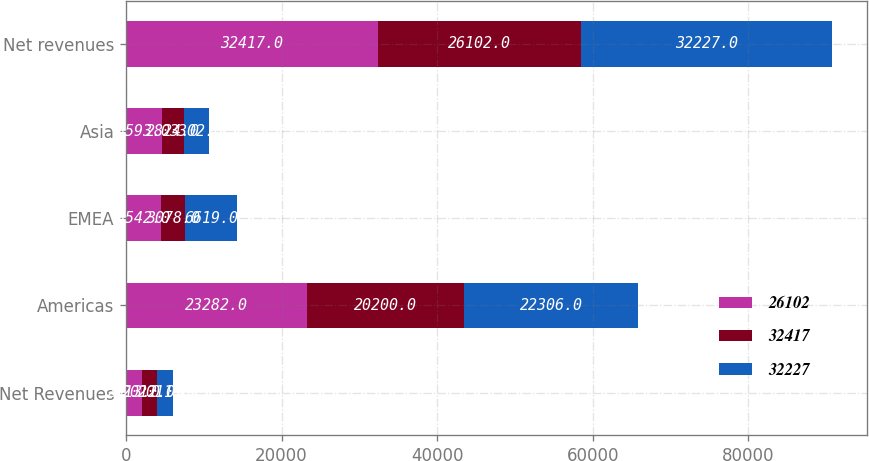Convert chart to OTSL. <chart><loc_0><loc_0><loc_500><loc_500><stacked_bar_chart><ecel><fcel>Net Revenues<fcel>Americas<fcel>EMEA<fcel>Asia<fcel>Net revenues<nl><fcel>26102<fcel>2013<fcel>23282<fcel>4542<fcel>4593<fcel>32417<nl><fcel>32417<fcel>2012<fcel>20200<fcel>3078<fcel>2824<fcel>26102<nl><fcel>32227<fcel>2011<fcel>22306<fcel>6619<fcel>3302<fcel>32227<nl></chart> 